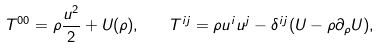<formula> <loc_0><loc_0><loc_500><loc_500>T ^ { 0 0 } = \rho \frac { { u } ^ { 2 } } { 2 } + U ( \rho ) , \quad T ^ { i j } = \rho u ^ { i } u ^ { j } - \delta ^ { i j } ( U - \rho \partial _ { \rho } U ) ,</formula> 